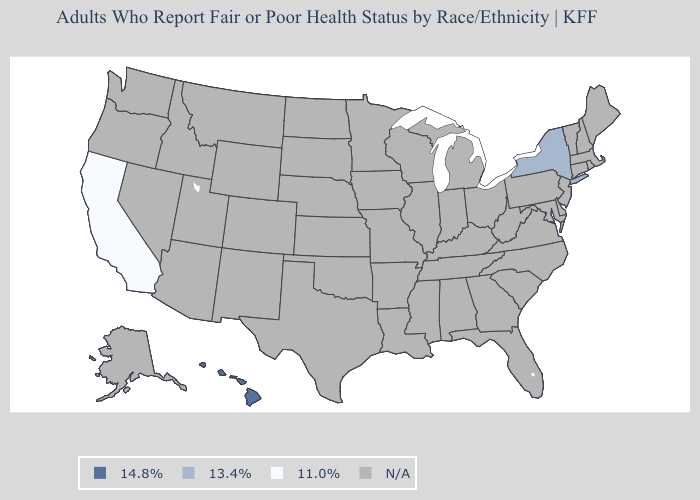What is the value of California?
Answer briefly. 11.0%. Name the states that have a value in the range 14.8%?
Be succinct. Hawaii. What is the value of Arkansas?
Give a very brief answer. N/A. Is the legend a continuous bar?
Be succinct. No. Does the first symbol in the legend represent the smallest category?
Short answer required. No. Name the states that have a value in the range 11.0%?
Keep it brief. California. What is the value of Utah?
Concise answer only. N/A. Name the states that have a value in the range 11.0%?
Keep it brief. California. What is the value of California?
Answer briefly. 11.0%. What is the value of South Dakota?
Write a very short answer. N/A. 